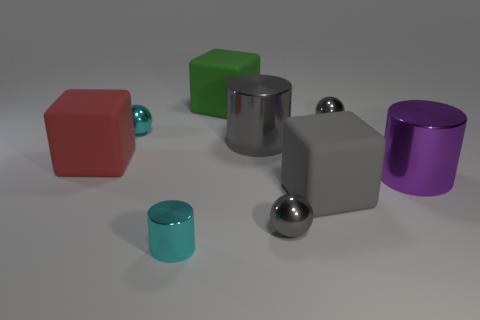What color is the shiny cylinder to the right of the gray metal ball that is in front of the red rubber cube?
Give a very brief answer. Purple. There is a red matte object; is it the same shape as the small object that is to the left of the cyan metallic cylinder?
Provide a succinct answer. No. The tiny cyan ball behind the tiny gray metal ball that is in front of the big matte object that is to the left of the cyan metal ball is made of what material?
Your answer should be very brief. Metal. Is there a cylinder that has the same size as the green thing?
Offer a very short reply. Yes. What size is the purple thing that is the same material as the gray cylinder?
Your answer should be very brief. Large. The purple object has what shape?
Offer a terse response. Cylinder. Are the red cube and the small ball to the left of the green rubber thing made of the same material?
Make the answer very short. No. What number of objects are either gray rubber blocks or blue shiny spheres?
Offer a terse response. 1. Are any large gray blocks visible?
Ensure brevity in your answer.  Yes. The tiny gray metallic object that is in front of the small gray metal object that is on the right side of the gray rubber block is what shape?
Your response must be concise. Sphere. 